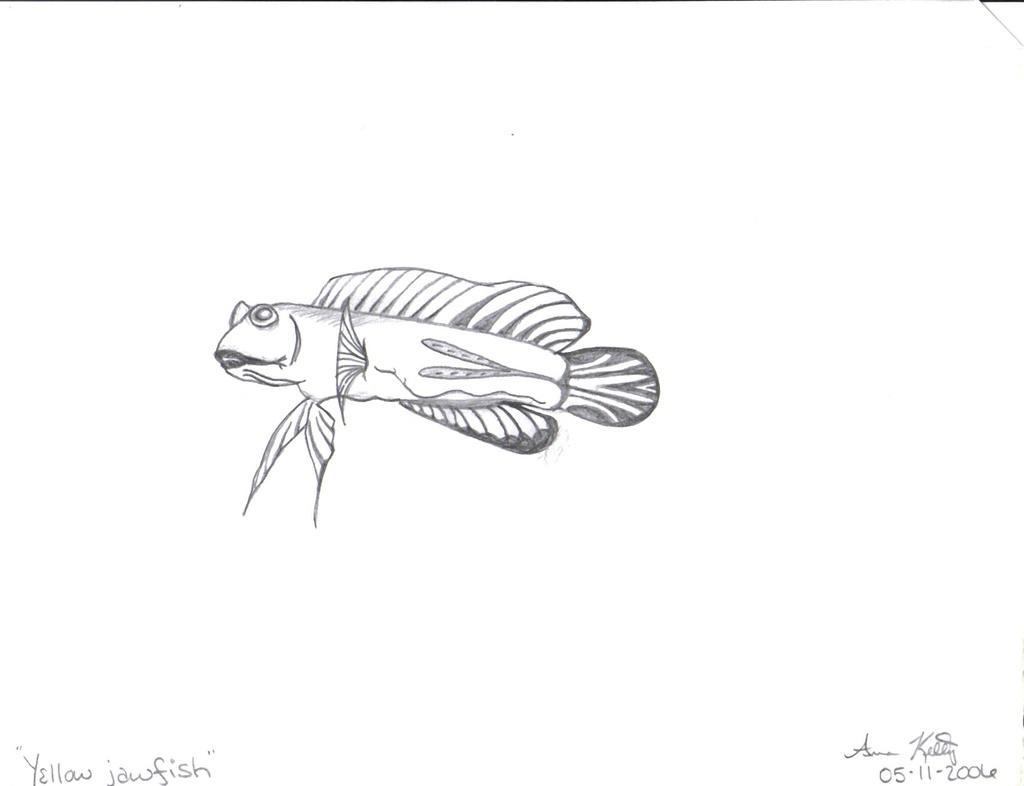Describe this image in one or two sentences. In this image, we can see a sketch. There is a written text in the bottom left of the image. 